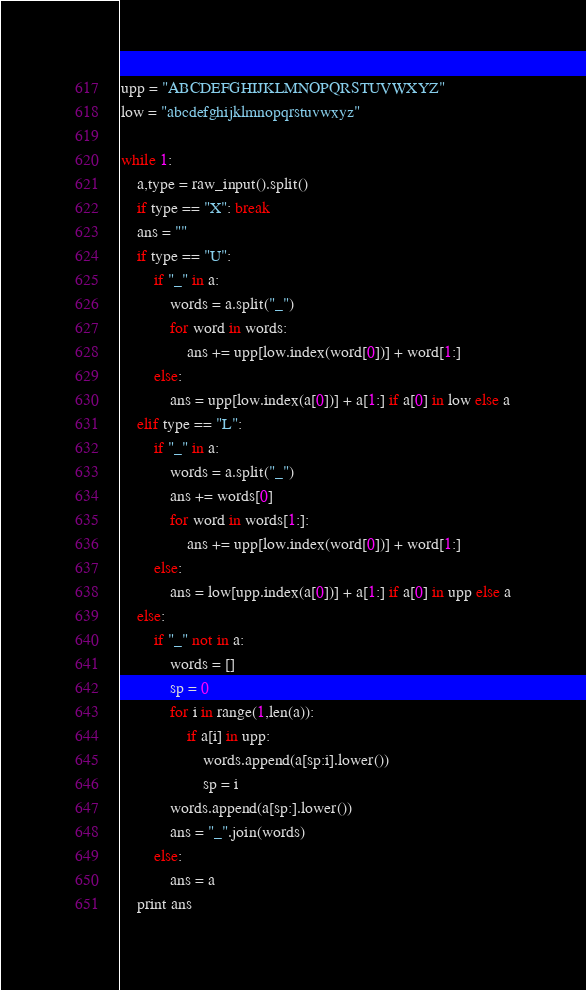Convert code to text. <code><loc_0><loc_0><loc_500><loc_500><_Python_>upp = "ABCDEFGHIJKLMNOPQRSTUVWXYZ"
low = "abcdefghijklmnopqrstuvwxyz"

while 1:
	a,type = raw_input().split()
	if type == "X": break
	ans = ""
	if type == "U":
		if "_" in a:
			words = a.split("_")
			for word in words:
				ans += upp[low.index(word[0])] + word[1:]
		else:
			ans = upp[low.index(a[0])] + a[1:] if a[0] in low else a
	elif type == "L":
		if "_" in a:
			words = a.split("_")
			ans += words[0]
			for word in words[1:]:
				ans += upp[low.index(word[0])] + word[1:]
		else:
			ans = low[upp.index(a[0])] + a[1:] if a[0] in upp else a
	else:
		if "_" not in a:
			words = []
			sp = 0
			for i in range(1,len(a)):
				if a[i] in upp:
					words.append(a[sp:i].lower())
					sp = i
			words.append(a[sp:].lower())
			ans = "_".join(words)
		else:
			ans = a
	print ans</code> 